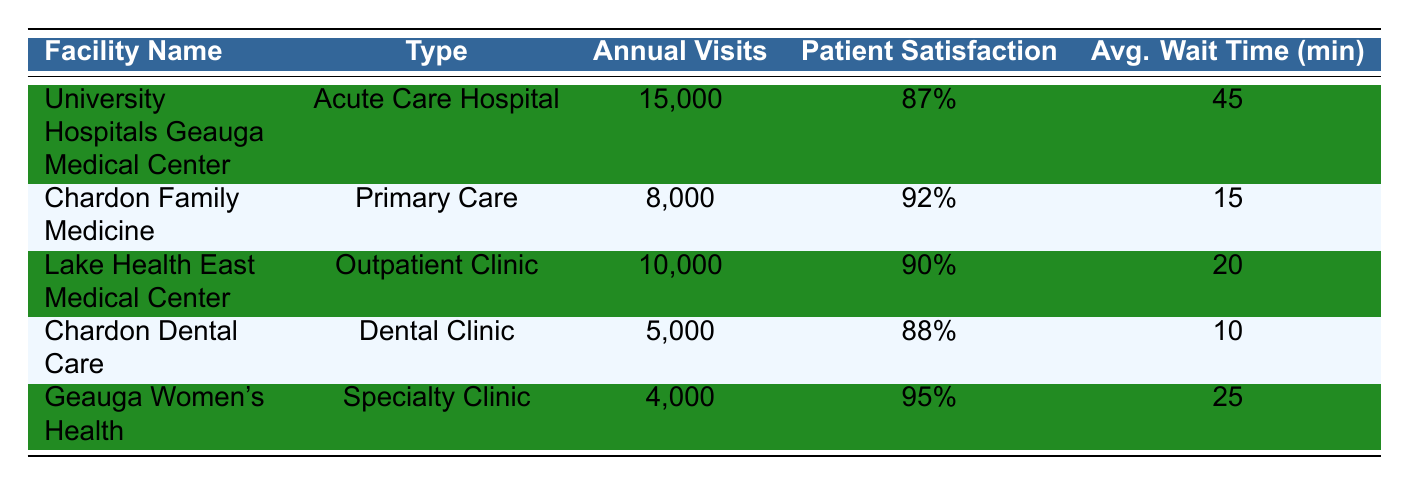What is the patient satisfaction rating for Chardon Family Medicine? The table provides the patient satisfaction rating for each facility. For Chardon Family Medicine, the rating is listed as 92%.
Answer: 92% Which facility has the highest number of annual visits? By looking at the 'Annual Visits' column, University Hospitals Geauga Medical Center has 15,000 visits, which is the highest compared to other facilities.
Answer: University Hospitals Geauga Medical Center What is the average wait time for patients at Chardon Dental Care? The 'Avg. Wait Time (min)' column indicates that the average wait time for Chardon Dental Care is 10 minutes.
Answer: 10 Is the patient satisfaction rating for Lake Health East Medical Center above 90%? By checking the patient satisfaction rating for Lake Health East Medical Center in the table, it shows 90%, which is not above 90%.
Answer: No What is the combined number of annual visits for all the facilities listed? To find the combined number of annual visits, we add the visits from all facilities: 15,000 + 8,000 + 10,000 + 5,000 + 4,000 = 42,000.
Answer: 42,000 Which facility type has the lowest average wait time? Looking at the 'Avg. Wait Time (min)' column, Chardon Dental Care has the lowest wait time of 10 minutes compared to the others.
Answer: Dental Clinic How many facilities have a patient satisfaction rating of 90% or higher? By checking the patient satisfaction ratings, the facilities with ratings of 90% or higher are Chardon Family Medicine (92%), Lake Health East Medical Center (90%), and Geauga Women's Health (95%). This gives us a total of 3 facilities.
Answer: 3 What is the difference in annual visits between University Hospitals Geauga Medical Center and Geauga Women's Health? The annual visits for University Hospitals Geauga Medical Center are 15,000 and for Geauga Women's Health are 4,000. The difference is calculated as 15,000 - 4,000 = 11,000.
Answer: 11,000 Which facility has the highest patient satisfaction rating, and what is that rating? From the table, Geauga Women's Health has the highest patient satisfaction rating of 95%.
Answer: Geauga Women's Health, 95% 